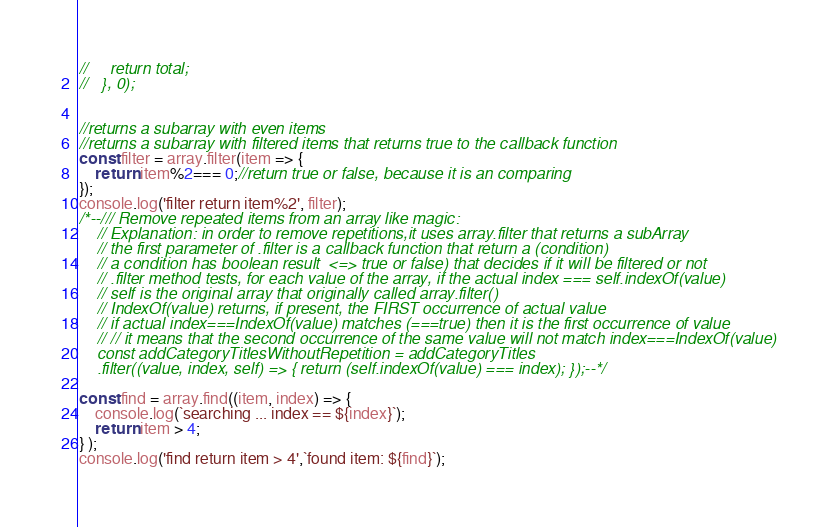<code> <loc_0><loc_0><loc_500><loc_500><_JavaScript_>//     return total;
//   }, 0);


//returns a subarray with even items 
//returns a subarray with filtered items that returns true to the callback function
const filter = array.filter(item => {
    return item%2=== 0;//return true or false, because it is an comparing 
});
console.log('filter return item%2', filter);
/*--/// Remove repeated items from an array like magic:
    // Explanation: in order to remove repetitions,it uses array.filter that returns a subArray
    // the first parameter of .filter is a callback function that return a (condition)
    // a condition has boolean result  <=> true or false) that decides if it will be filtered or not
    // .filter method tests, for each value of the array, if the actual index === self.indexOf(value)
    // self is the original array that originally called array.filter()
    // IndexOf(value) returns, if present, the FIRST occurrence of actual value
    // if actual index===IndexOf(value) matches (===true) then it is the first occurrence of value
    // // it means that the second occurrence of the same value will not match index===IndexOf(value)
    const addCategoryTitlesWithoutRepetition = addCategoryTitles
    .filter((value, index, self) => { return (self.indexOf(value) === index); });--*/

const find = array.find((item, index) => {
    console.log(`searching ... index == ${index}`);
    return item > 4; 
} );
console.log('find return item > 4',`found item: ${find}`);</code> 